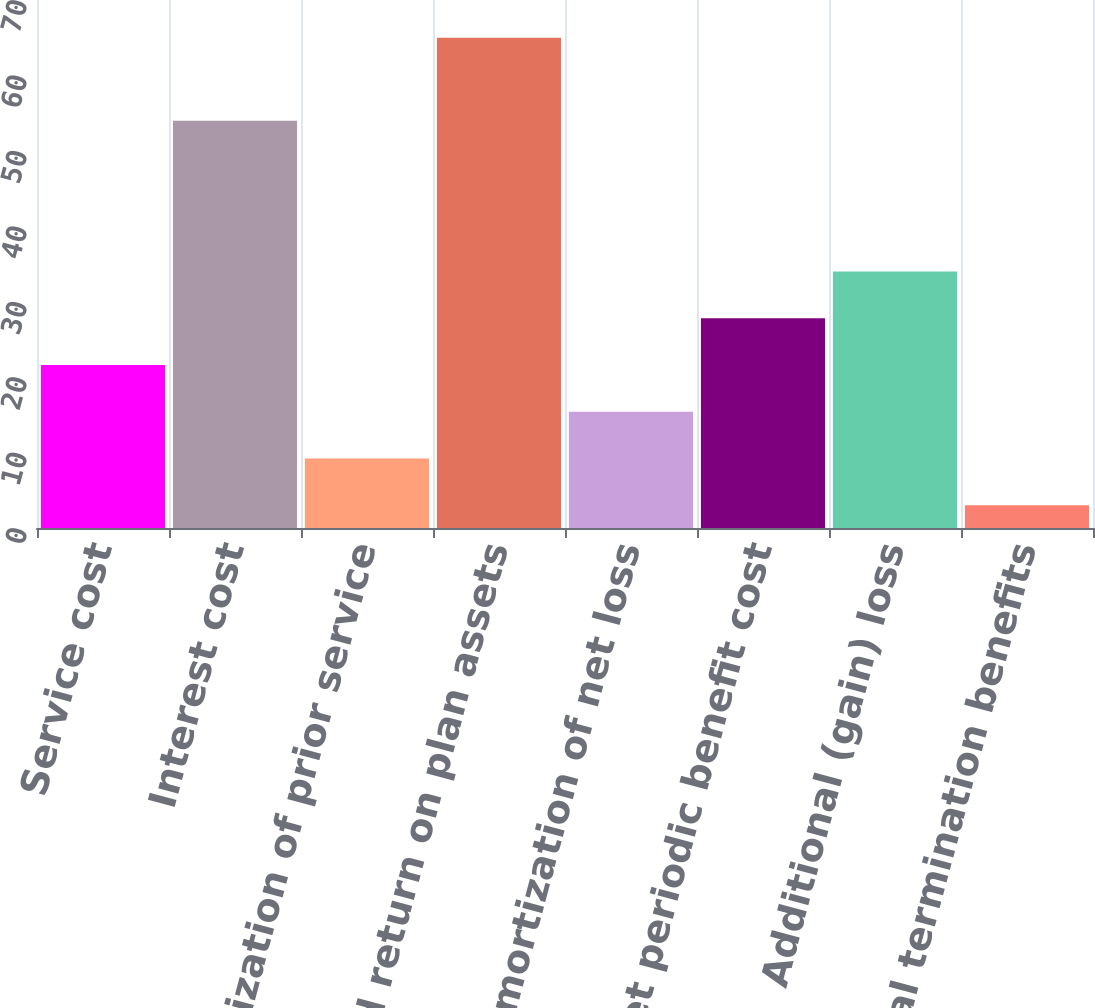<chart> <loc_0><loc_0><loc_500><loc_500><bar_chart><fcel>Service cost<fcel>Interest cost<fcel>Amortization of prior service<fcel>Expected return on plan assets<fcel>Amortization of net loss<fcel>Net periodic benefit cost<fcel>Additional (gain) loss<fcel>Special termination benefits<nl><fcel>21.6<fcel>54<fcel>9.2<fcel>65<fcel>15.4<fcel>27.8<fcel>34<fcel>3<nl></chart> 